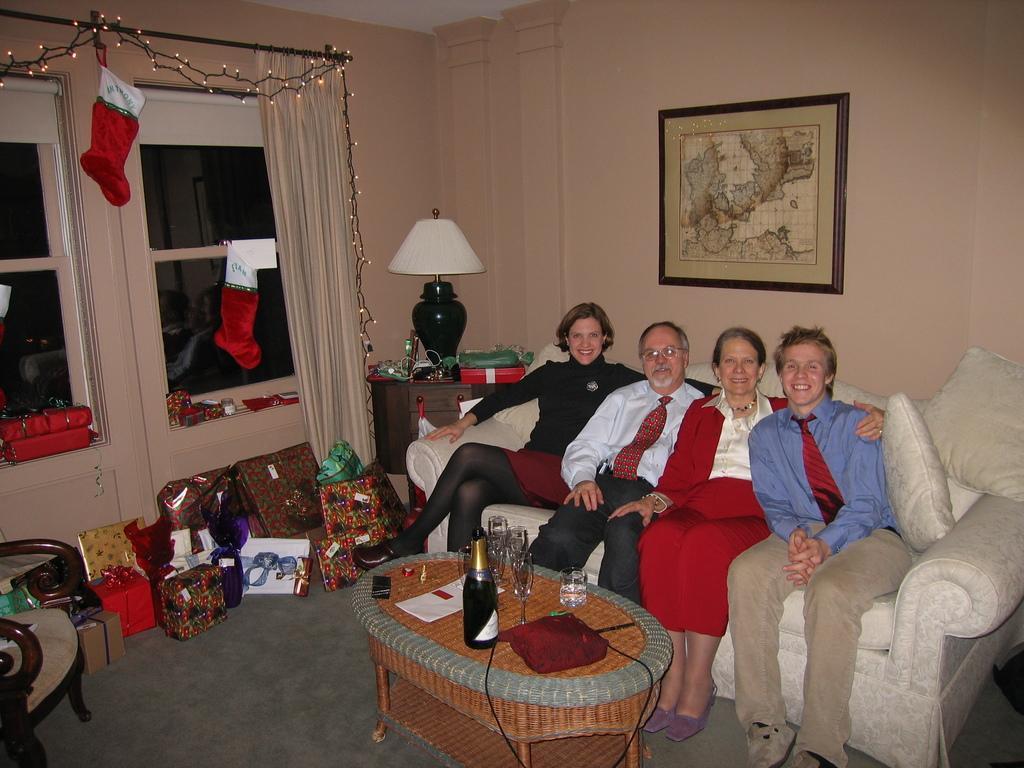Please provide a concise description of this image. There are four people sitting in a white sofa and there is a table in front of them which consists of a wine bottle and some glasses and there are gifts beside them. 